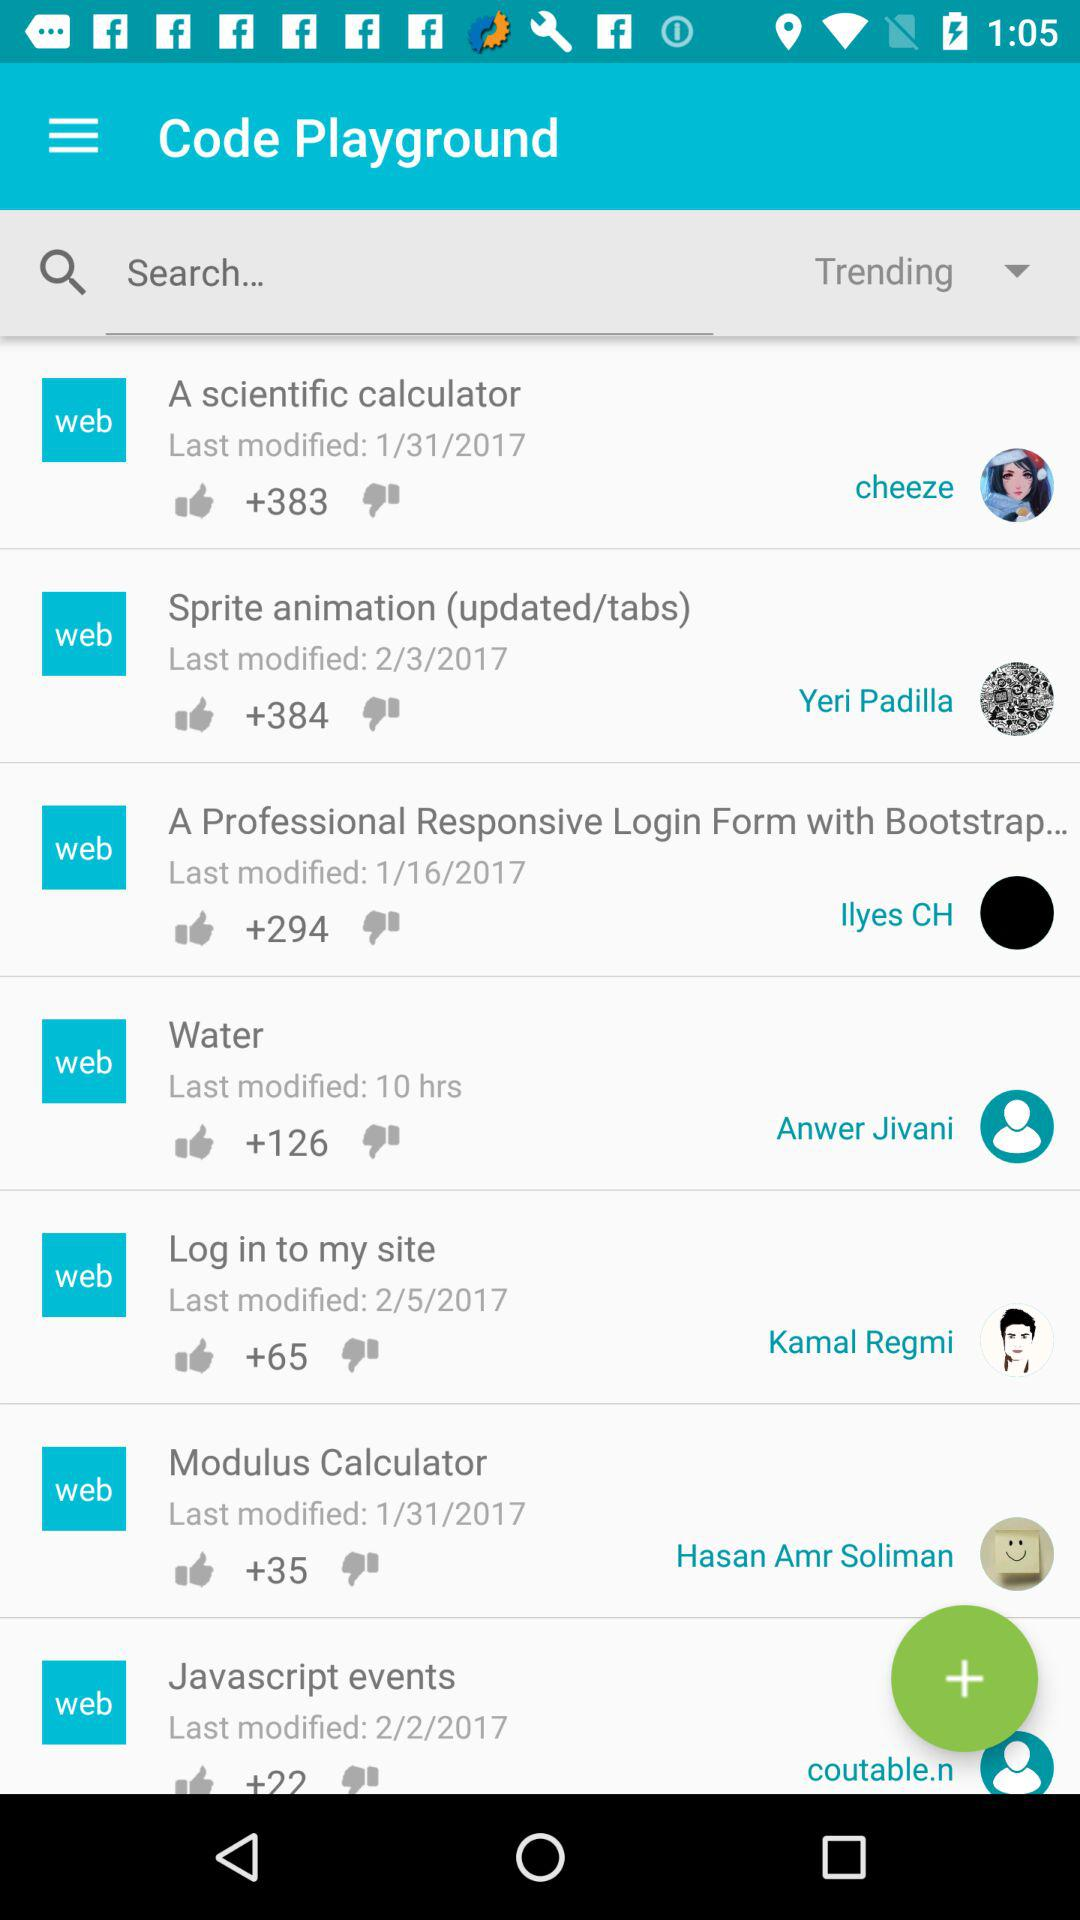What is the date of the last modification of sprite animation? The date of the last modification is February 3, 2017. 